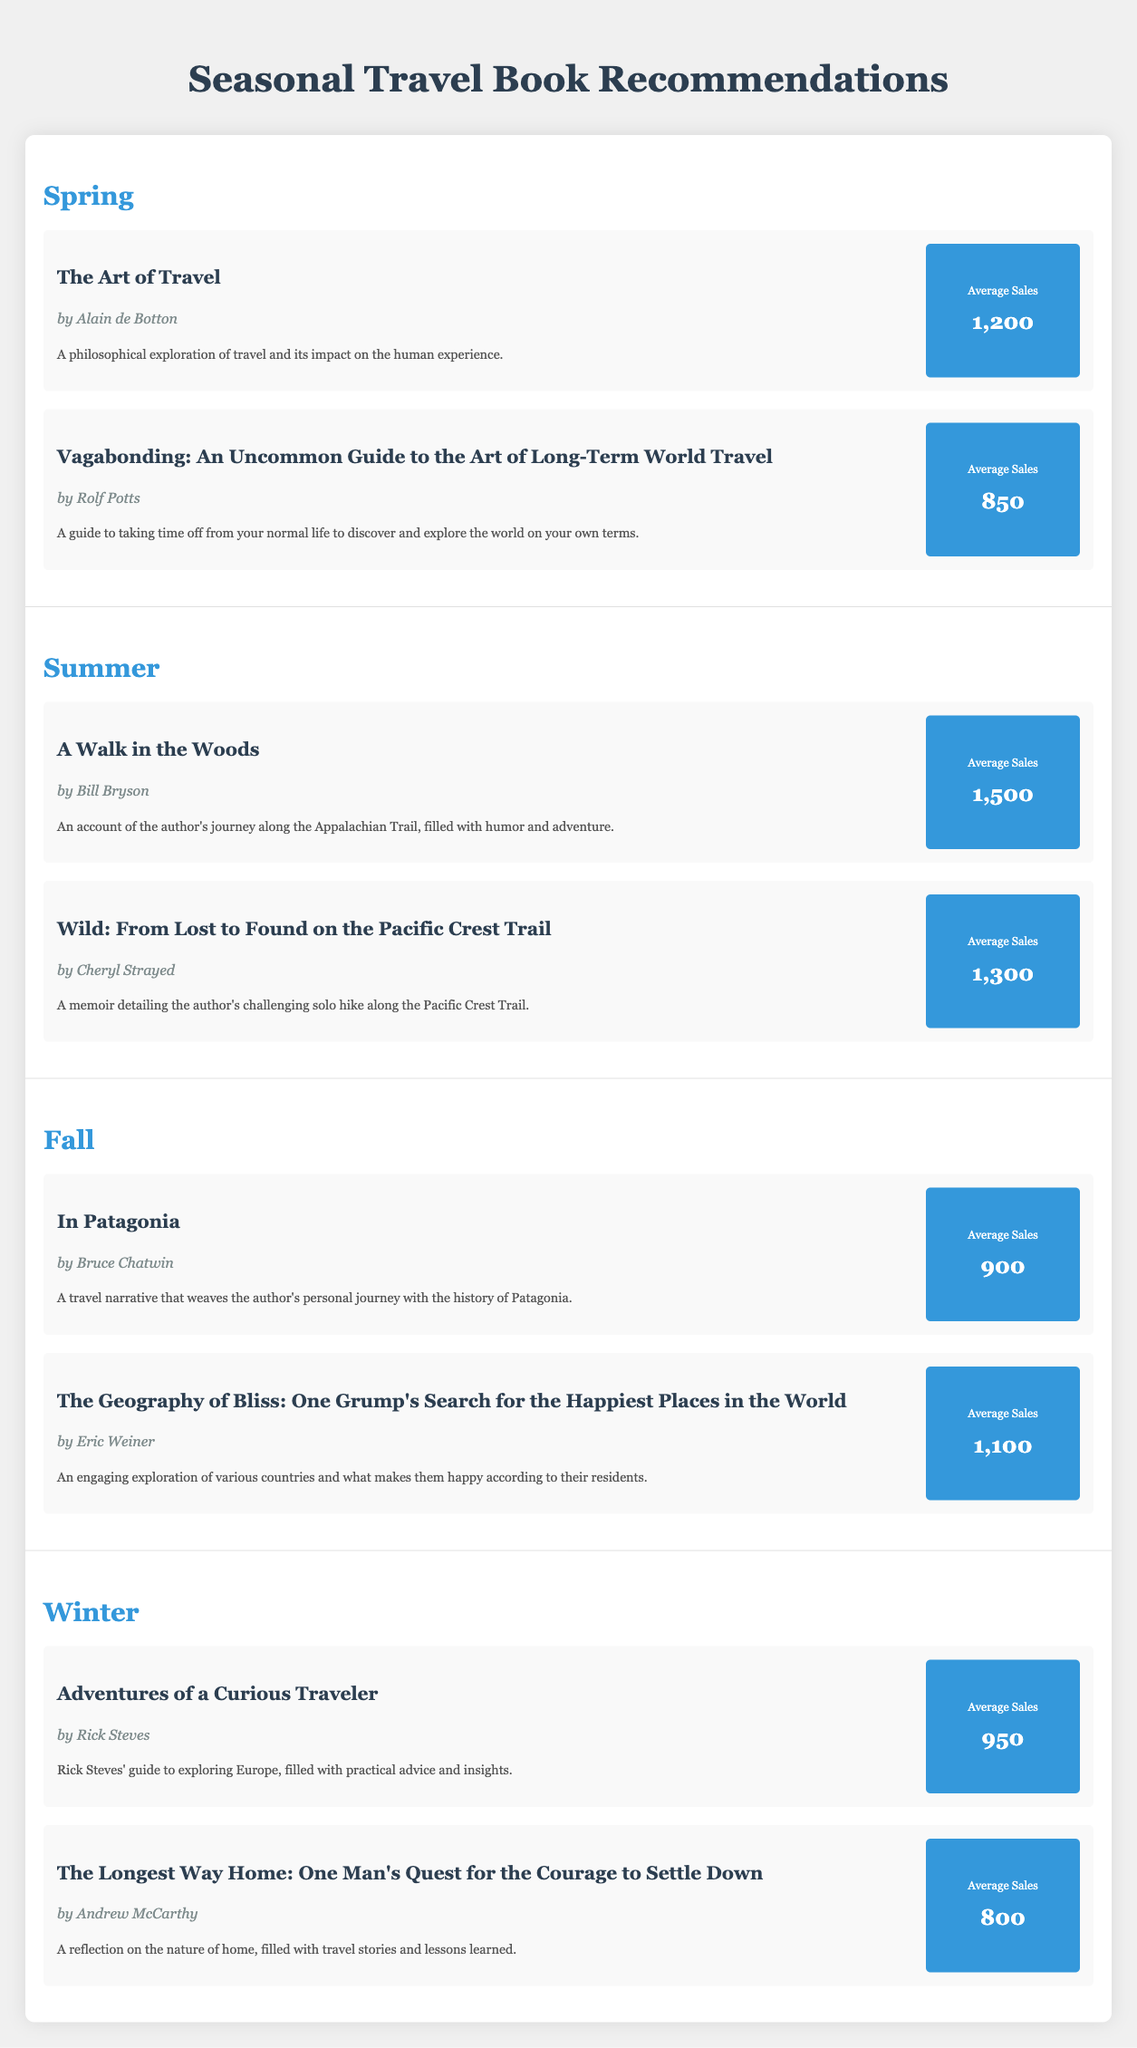What are the recommended books for summer? The table shows summer recommendations under the "Summer" section, which includes "A Walk in the Woods" by Bill Bryson and "Wild: From Lost to Found on the Pacific Crest Trail" by Cheryl Strayed.
Answer: "A Walk in the Woods" and "Wild" Which book had the highest average sales overall? To find the book with the highest average sales, we compare the average sales of all books listed. "A Walk in the Woods" has 1500 sales, which is higher than the others.
Answer: "A Walk in the Woods" What is the average sales of books recommended in the fall? The average sales can be calculated by adding the sales of the two fall books, "In Patagonia" (900) and "The Geography of Bliss" (1100), resulting in a total of 2000, and then dividing by the number of books (2): 2000/2 = 1000.
Answer: 1000 Are there any books with average sales below 900? Yes, "The Longest Way Home" by Andrew McCarthy has average sales of 800, which is below 900.
Answer: Yes What is the total average sales of all recommended books across seasons? To find this, add the average sales of all books: 1200 (Spring) + 850 (Spring) + 1500 (Summer) + 1300 (Summer) + 900 (Fall) + 1100 (Fall) + 950 (Winter) + 800 (Winter) = 7200. Then divide by the number of books (8): 7200/8 = 900.
Answer: 900 Which season has the lowest average sales of its recommended books? To find the season with the lowest average, calculate the averages for each season. Spring averages (1200 + 850)/2 = 1025, Summer (1500 + 1300)/2 = 1400, Fall (900 + 1100)/2 = 1000, Winter (950 + 800)/2 = 875. Winter has the lowest average.
Answer: Winter Is "Adventures of a Curious Traveler" recommended for spring? No, "Adventures of a Curious Traveler" is listed under the "Winter" section, so it is not recommended for spring.
Answer: No What are the descriptions of the books recommended in spring? The descriptions for spring books are: "The Art of Travel" explores the philosophical aspect of travel, and "Vagabonding" serves as a practical guide for long-term world travel.
Answer: "Philosophical exploration" and "Guide to long-term travel" 